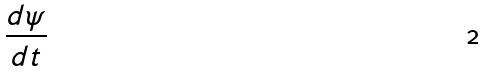<formula> <loc_0><loc_0><loc_500><loc_500>\frac { d \psi } { d t }</formula> 